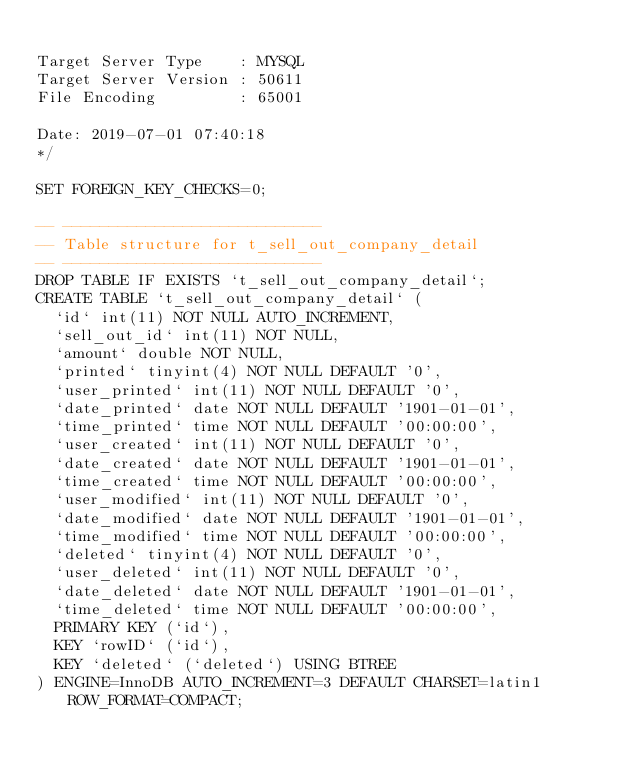Convert code to text. <code><loc_0><loc_0><loc_500><loc_500><_SQL_>
Target Server Type    : MYSQL
Target Server Version : 50611
File Encoding         : 65001

Date: 2019-07-01 07:40:18
*/

SET FOREIGN_KEY_CHECKS=0;

-- ----------------------------
-- Table structure for t_sell_out_company_detail
-- ----------------------------
DROP TABLE IF EXISTS `t_sell_out_company_detail`;
CREATE TABLE `t_sell_out_company_detail` (
  `id` int(11) NOT NULL AUTO_INCREMENT,
  `sell_out_id` int(11) NOT NULL,
  `amount` double NOT NULL,
  `printed` tinyint(4) NOT NULL DEFAULT '0',
  `user_printed` int(11) NOT NULL DEFAULT '0',
  `date_printed` date NOT NULL DEFAULT '1901-01-01',
  `time_printed` time NOT NULL DEFAULT '00:00:00',
  `user_created` int(11) NOT NULL DEFAULT '0',
  `date_created` date NOT NULL DEFAULT '1901-01-01',
  `time_created` time NOT NULL DEFAULT '00:00:00',
  `user_modified` int(11) NOT NULL DEFAULT '0',
  `date_modified` date NOT NULL DEFAULT '1901-01-01',
  `time_modified` time NOT NULL DEFAULT '00:00:00',
  `deleted` tinyint(4) NOT NULL DEFAULT '0',
  `user_deleted` int(11) NOT NULL DEFAULT '0',
  `date_deleted` date NOT NULL DEFAULT '1901-01-01',
  `time_deleted` time NOT NULL DEFAULT '00:00:00',
  PRIMARY KEY (`id`),
  KEY `rowID` (`id`),
  KEY `deleted` (`deleted`) USING BTREE
) ENGINE=InnoDB AUTO_INCREMENT=3 DEFAULT CHARSET=latin1 ROW_FORMAT=COMPACT;
</code> 